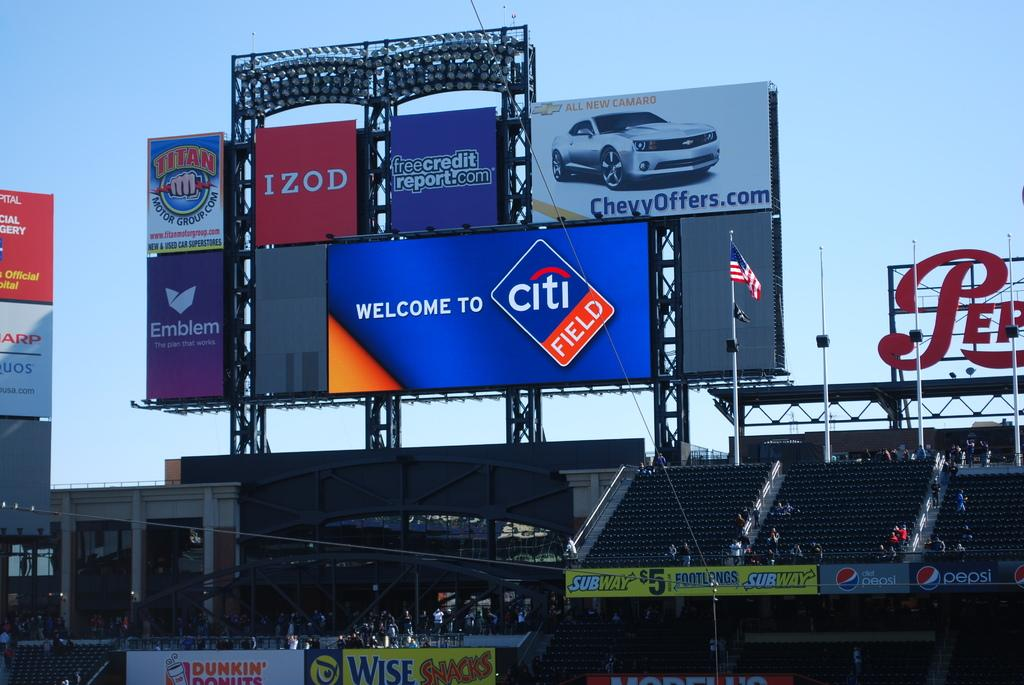<image>
Render a clear and concise summary of the photo. A digital scoreboard at CitiField with ads for Izod and Chevy. 